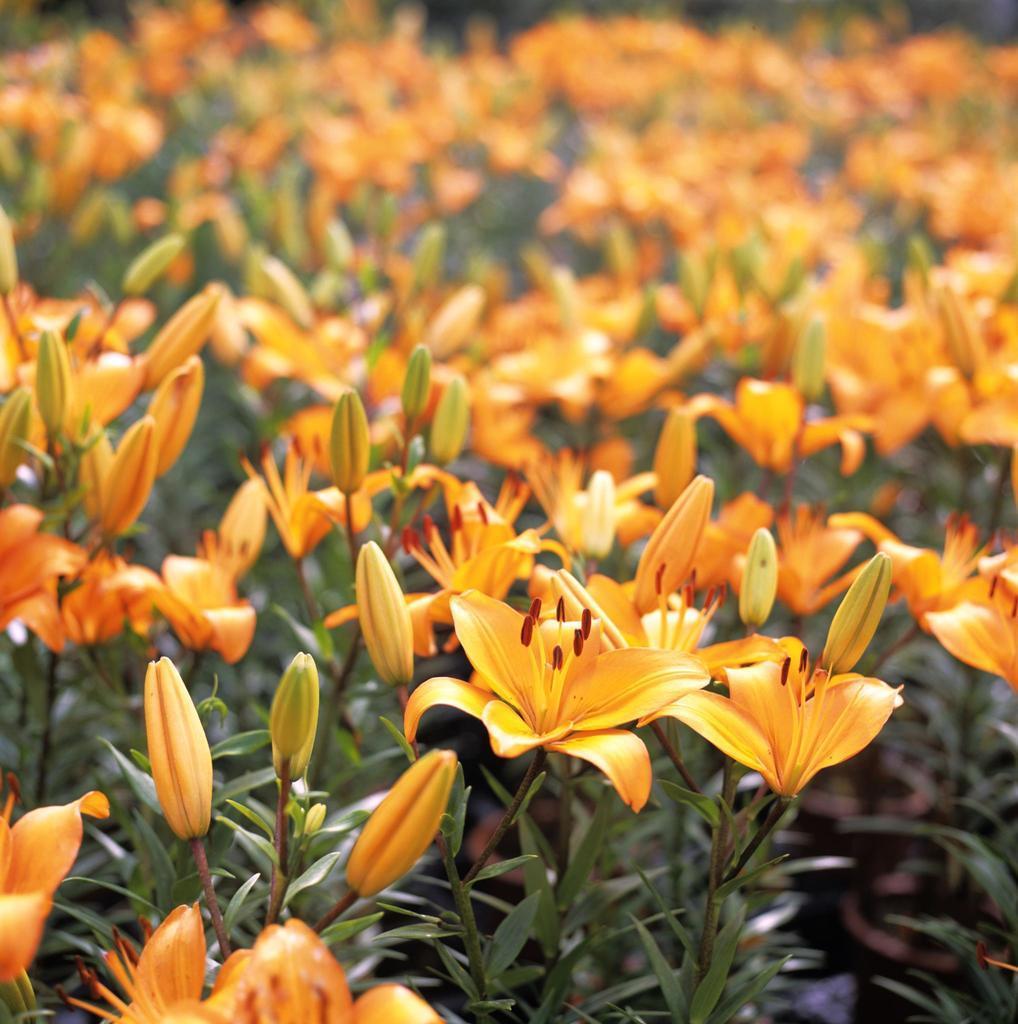Could you give a brief overview of what you see in this image? In this image I can see number of orange colour flowers, buds and plants. I can also see this image is little bit blurry in the background. 